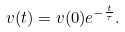Convert formula to latex. <formula><loc_0><loc_0><loc_500><loc_500>v ( t ) = v ( 0 ) e ^ { - \frac { t } { \tau } } .</formula> 